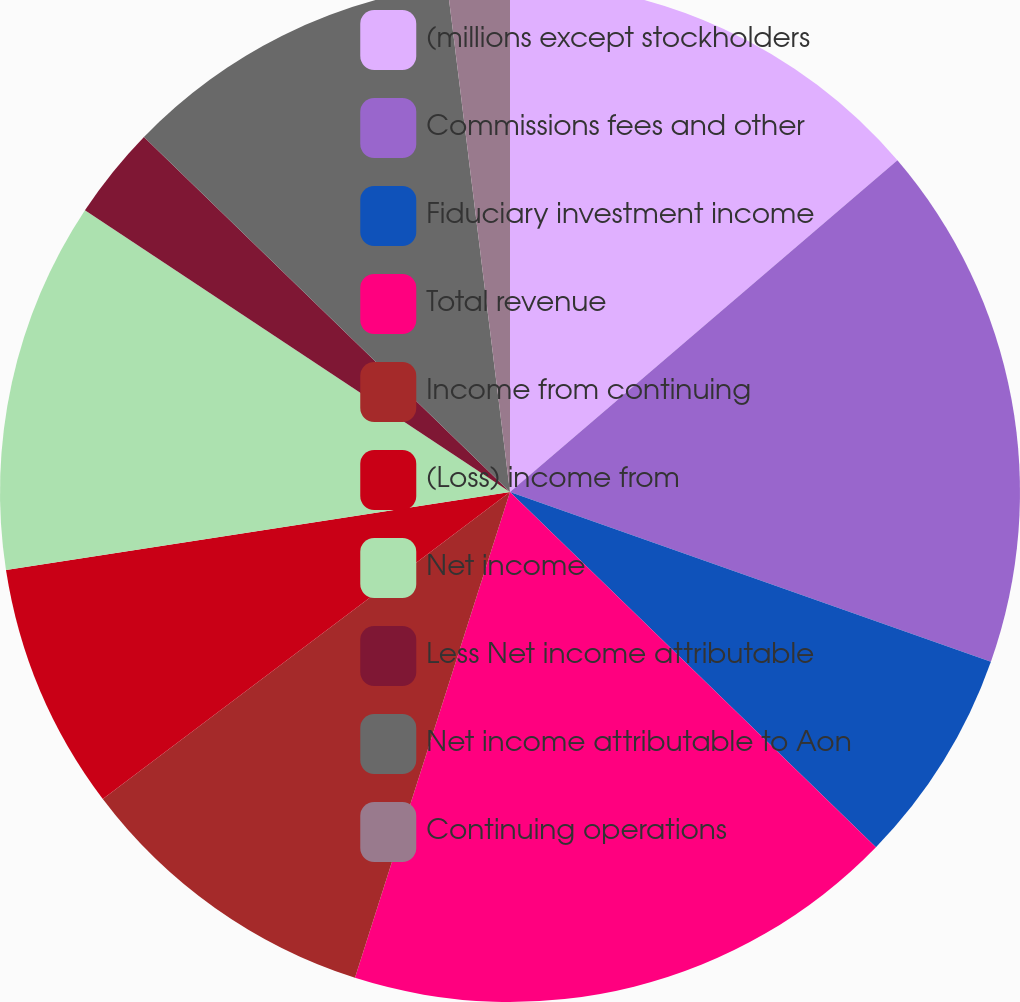<chart> <loc_0><loc_0><loc_500><loc_500><pie_chart><fcel>(millions except stockholders<fcel>Commissions fees and other<fcel>Fiduciary investment income<fcel>Total revenue<fcel>Income from continuing<fcel>(Loss) income from<fcel>Net income<fcel>Less Net income attributable<fcel>Net income attributable to Aon<fcel>Continuing operations<nl><fcel>13.73%<fcel>16.67%<fcel>6.86%<fcel>17.65%<fcel>9.8%<fcel>7.84%<fcel>11.76%<fcel>2.94%<fcel>10.78%<fcel>1.96%<nl></chart> 